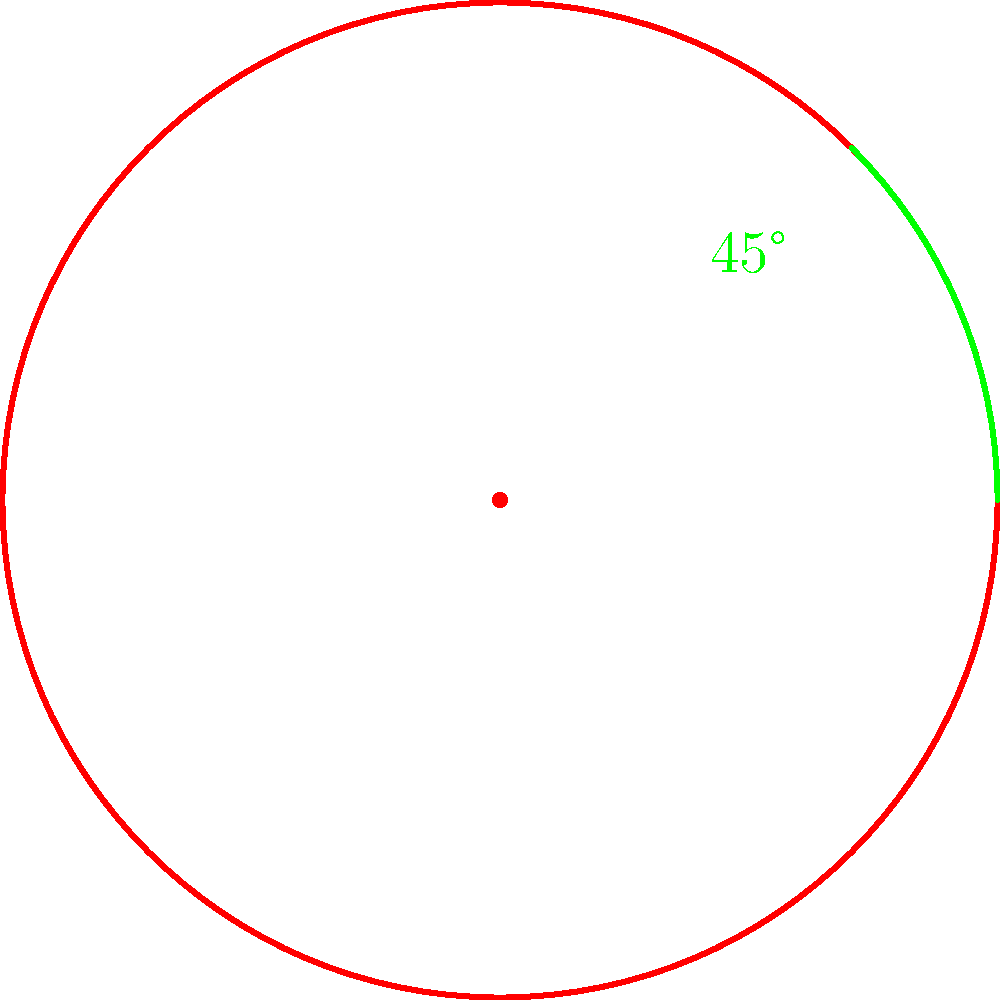In your local Balinese art, you find a circular mandala pattern with 8-fold rotational symmetry. If you rotate this pattern by $45°$ clockwise, how many degrees would you need to rotate it further to return it to its original position? Let's approach this step-by-step:

1) First, we need to understand the rotational symmetry of the mandala:
   - The mandala has 8-fold rotational symmetry.
   - This means it repeats its pattern every $\frac{360°}{8} = 45°$.

2) We're told the mandala is rotated $45°$ clockwise:
   - This is equivalent to one full step in its rotational symmetry.

3) To return to the original position:
   - We need to complete a full $360°$ rotation.
   - We've already rotated $45°$.
   - So, we need to rotate: $360° - 45° = 315°$.

4) Alternatively, we could rotate counterclockwise:
   - This would require a rotation of $45°$ counterclockwise.
   - In mathematical terms, this is equivalent to $-45°$ or $315°$ clockwise.

Therefore, to return the mandala to its original position after a $45°$ clockwise rotation, we need to rotate it a further $315°$ clockwise (or $45°$ counterclockwise).
Answer: $315°$ 